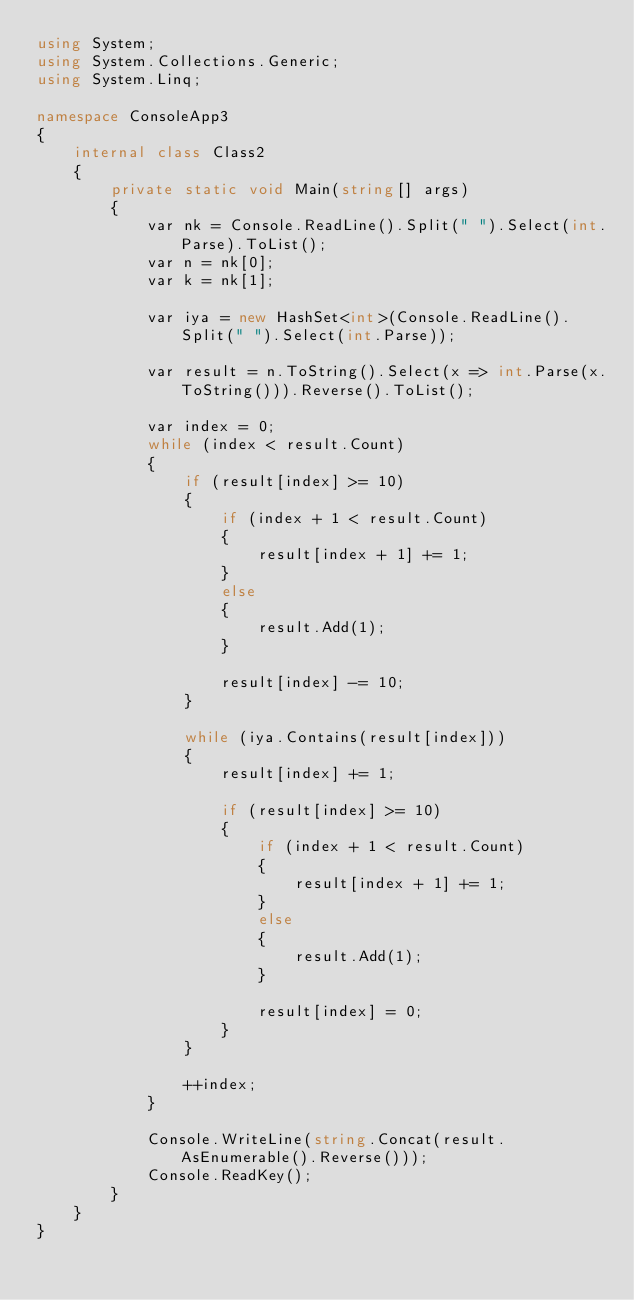<code> <loc_0><loc_0><loc_500><loc_500><_C#_>using System;
using System.Collections.Generic;
using System.Linq;

namespace ConsoleApp3
{
    internal class Class2
    {
        private static void Main(string[] args)
        {
            var nk = Console.ReadLine().Split(" ").Select(int.Parse).ToList();
            var n = nk[0];
            var k = nk[1];

            var iya = new HashSet<int>(Console.ReadLine().Split(" ").Select(int.Parse));

            var result = n.ToString().Select(x => int.Parse(x.ToString())).Reverse().ToList();

            var index = 0;
            while (index < result.Count)
            {
                if (result[index] >= 10)
                {
                    if (index + 1 < result.Count)
                    {
                        result[index + 1] += 1;
                    }
                    else
                    {
                        result.Add(1);
                    }

                    result[index] -= 10;
                }

                while (iya.Contains(result[index]))
                {
                    result[index] += 1;

                    if (result[index] >= 10)
                    {
                        if (index + 1 < result.Count)
                        {
                            result[index + 1] += 1;
                        }
                        else
                        {
                            result.Add(1);
                        }

                        result[index] = 0;
                    }
                }

                ++index;
            }

            Console.WriteLine(string.Concat(result.AsEnumerable().Reverse()));
            Console.ReadKey();
        }
    }
}</code> 